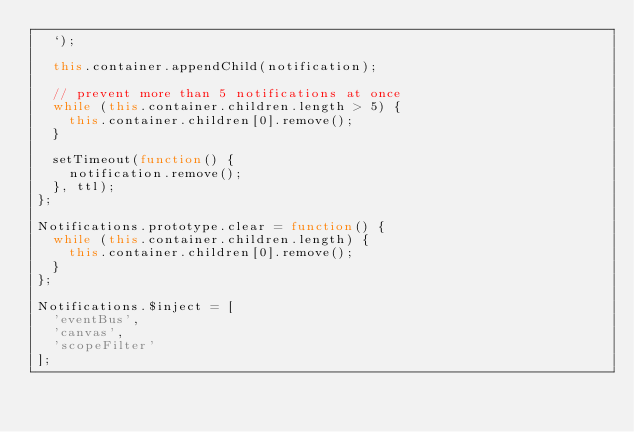Convert code to text. <code><loc_0><loc_0><loc_500><loc_500><_JavaScript_>  `);

  this.container.appendChild(notification);

  // prevent more than 5 notifications at once
  while (this.container.children.length > 5) {
    this.container.children[0].remove();
  }

  setTimeout(function() {
    notification.remove();
  }, ttl);
};

Notifications.prototype.clear = function() {
  while (this.container.children.length) {
    this.container.children[0].remove();
  }
};

Notifications.$inject = [
  'eventBus',
  'canvas',
  'scopeFilter'
];</code> 